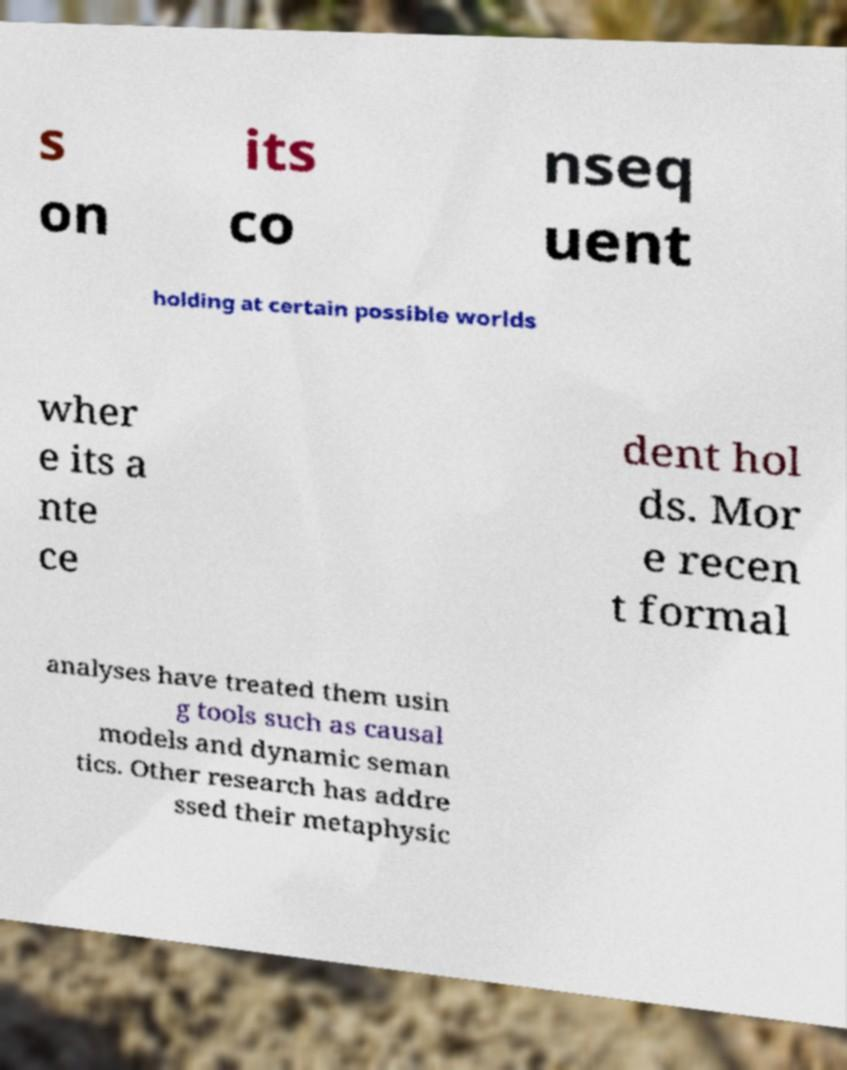Could you assist in decoding the text presented in this image and type it out clearly? s on its co nseq uent holding at certain possible worlds wher e its a nte ce dent hol ds. Mor e recen t formal analyses have treated them usin g tools such as causal models and dynamic seman tics. Other research has addre ssed their metaphysic 